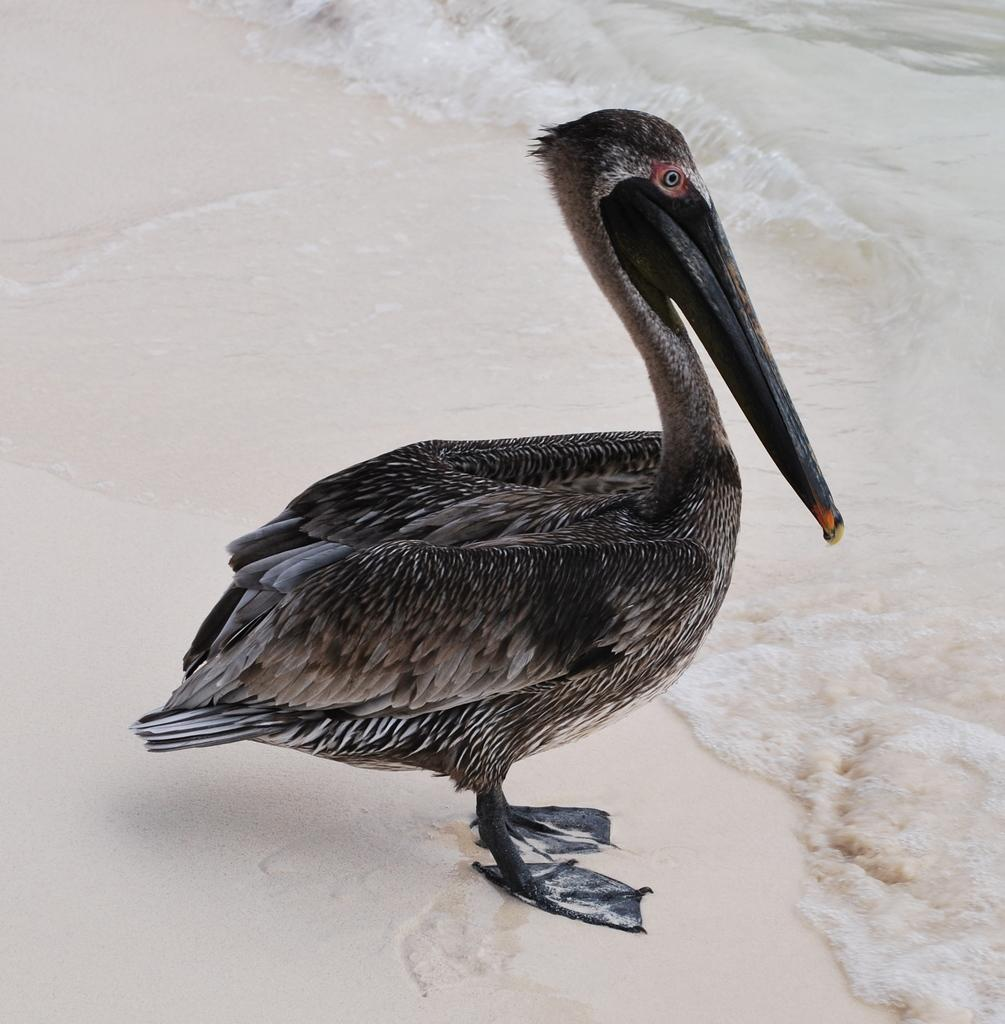What animal is in the foreground of the image? There is a duck in the foreground of the image. What surface is the duck standing on? The duck is on the sand. What can be seen in the background of the image? Water is visible in the background of the image. How many dimes are scattered around the duck in the image? There are no dimes present in the image; it features a duck on the sand with water visible in the background. 